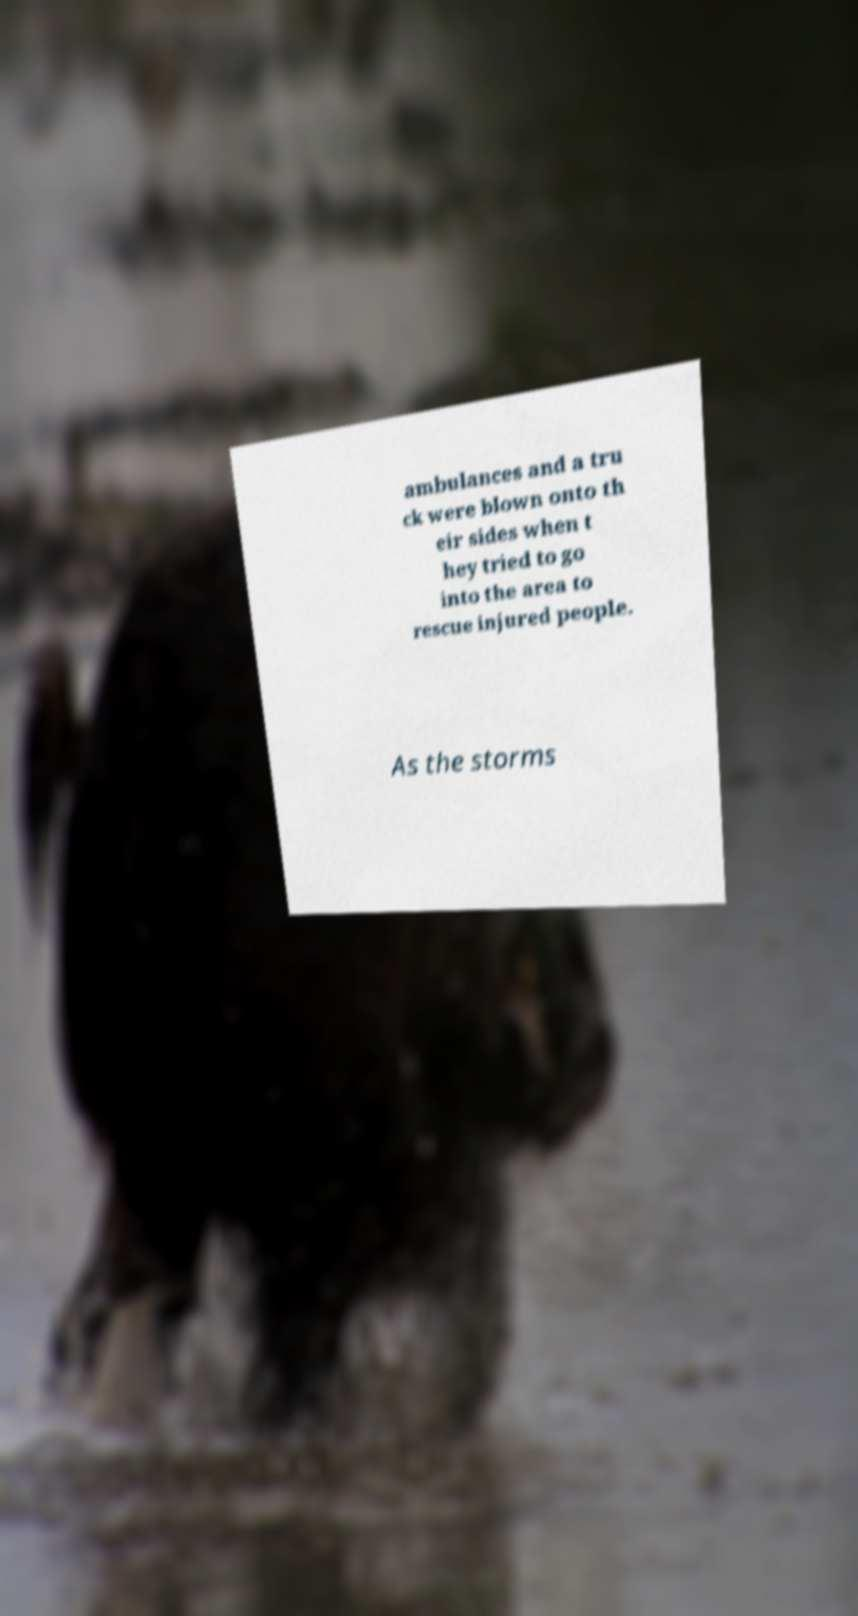Please read and relay the text visible in this image. What does it say? ambulances and a tru ck were blown onto th eir sides when t hey tried to go into the area to rescue injured people. As the storms 